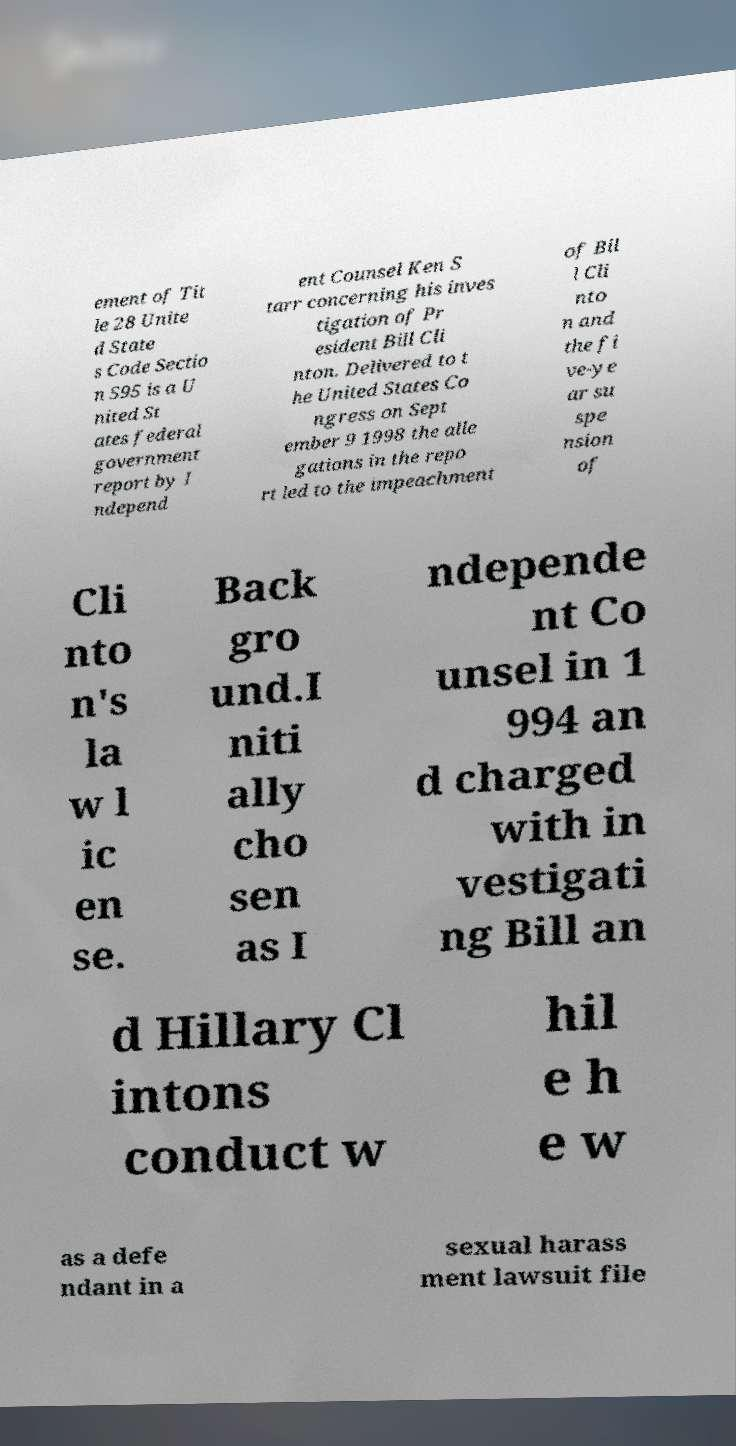Please identify and transcribe the text found in this image. ement of Tit le 28 Unite d State s Code Sectio n 595 is a U nited St ates federal government report by I ndepend ent Counsel Ken S tarr concerning his inves tigation of Pr esident Bill Cli nton. Delivered to t he United States Co ngress on Sept ember 9 1998 the alle gations in the repo rt led to the impeachment of Bil l Cli nto n and the fi ve-ye ar su spe nsion of Cli nto n's la w l ic en se. Back gro und.I niti ally cho sen as I ndepende nt Co unsel in 1 994 an d charged with in vestigati ng Bill an d Hillary Cl intons conduct w hil e h e w as a defe ndant in a sexual harass ment lawsuit file 